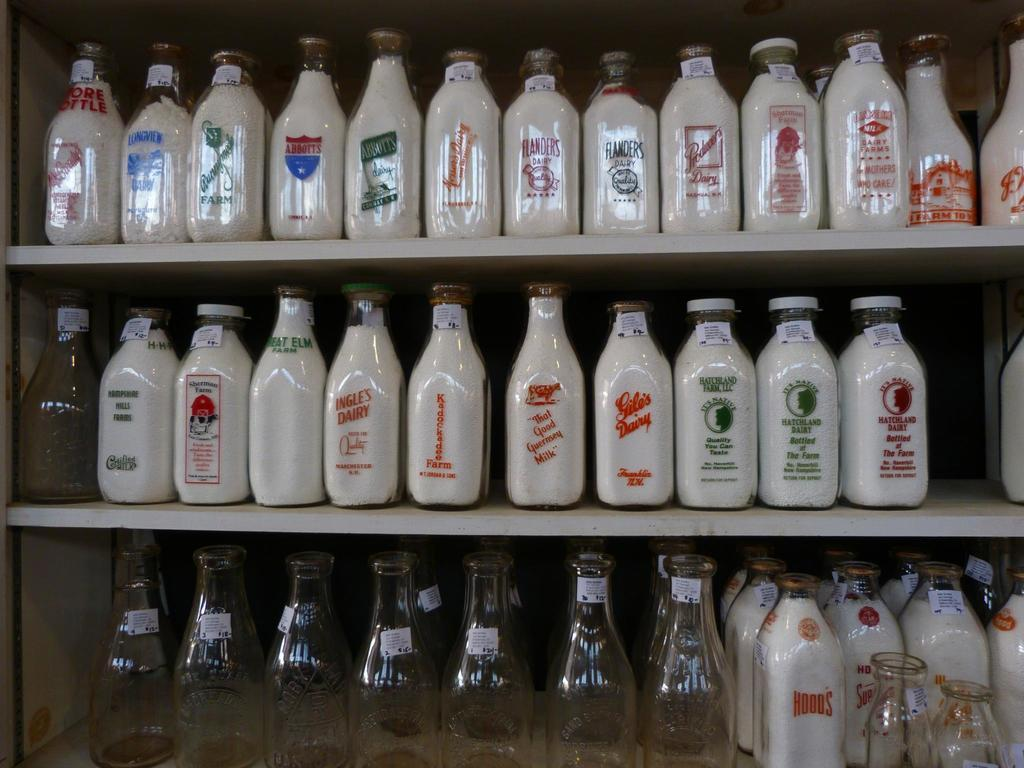Provide a one-sentence caption for the provided image. Many milk bottles on a shelf with one on the middle shelf by Kadockadee Farms. 